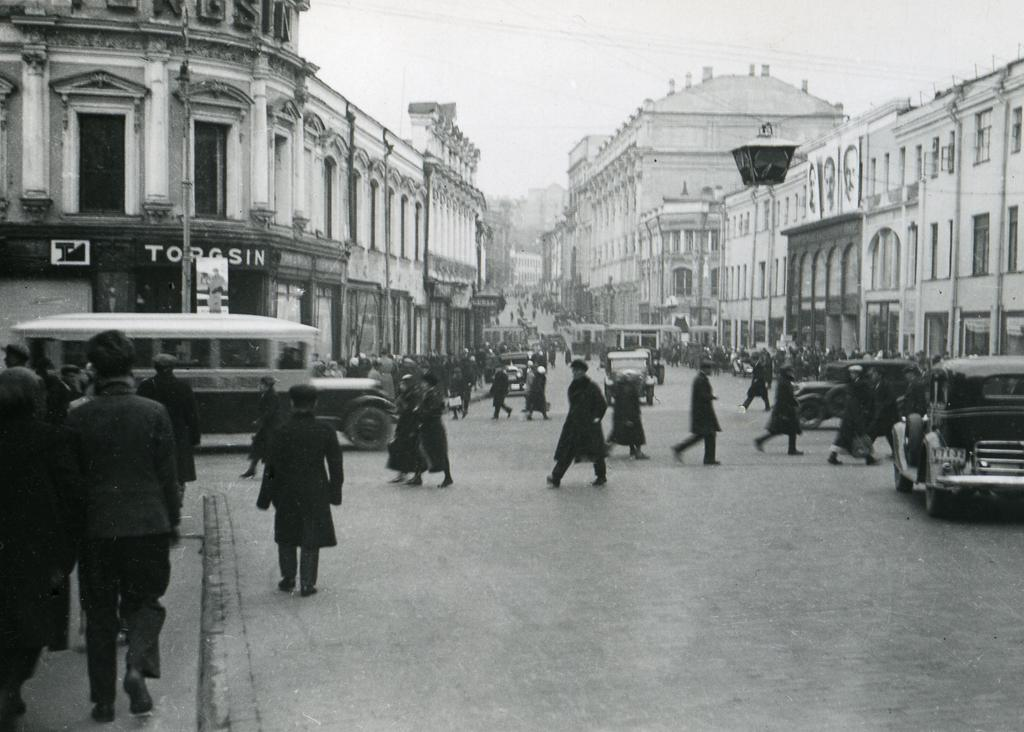What type of structures can be seen in the image? There are buildings in the image. Who or what else is present in the image? There are people and vehicles on the road in the image. What can be seen in the background of the image? The sky is visible in the background of the image. What type of blade is being used by the team in the image? There is no team or blade present in the image. 